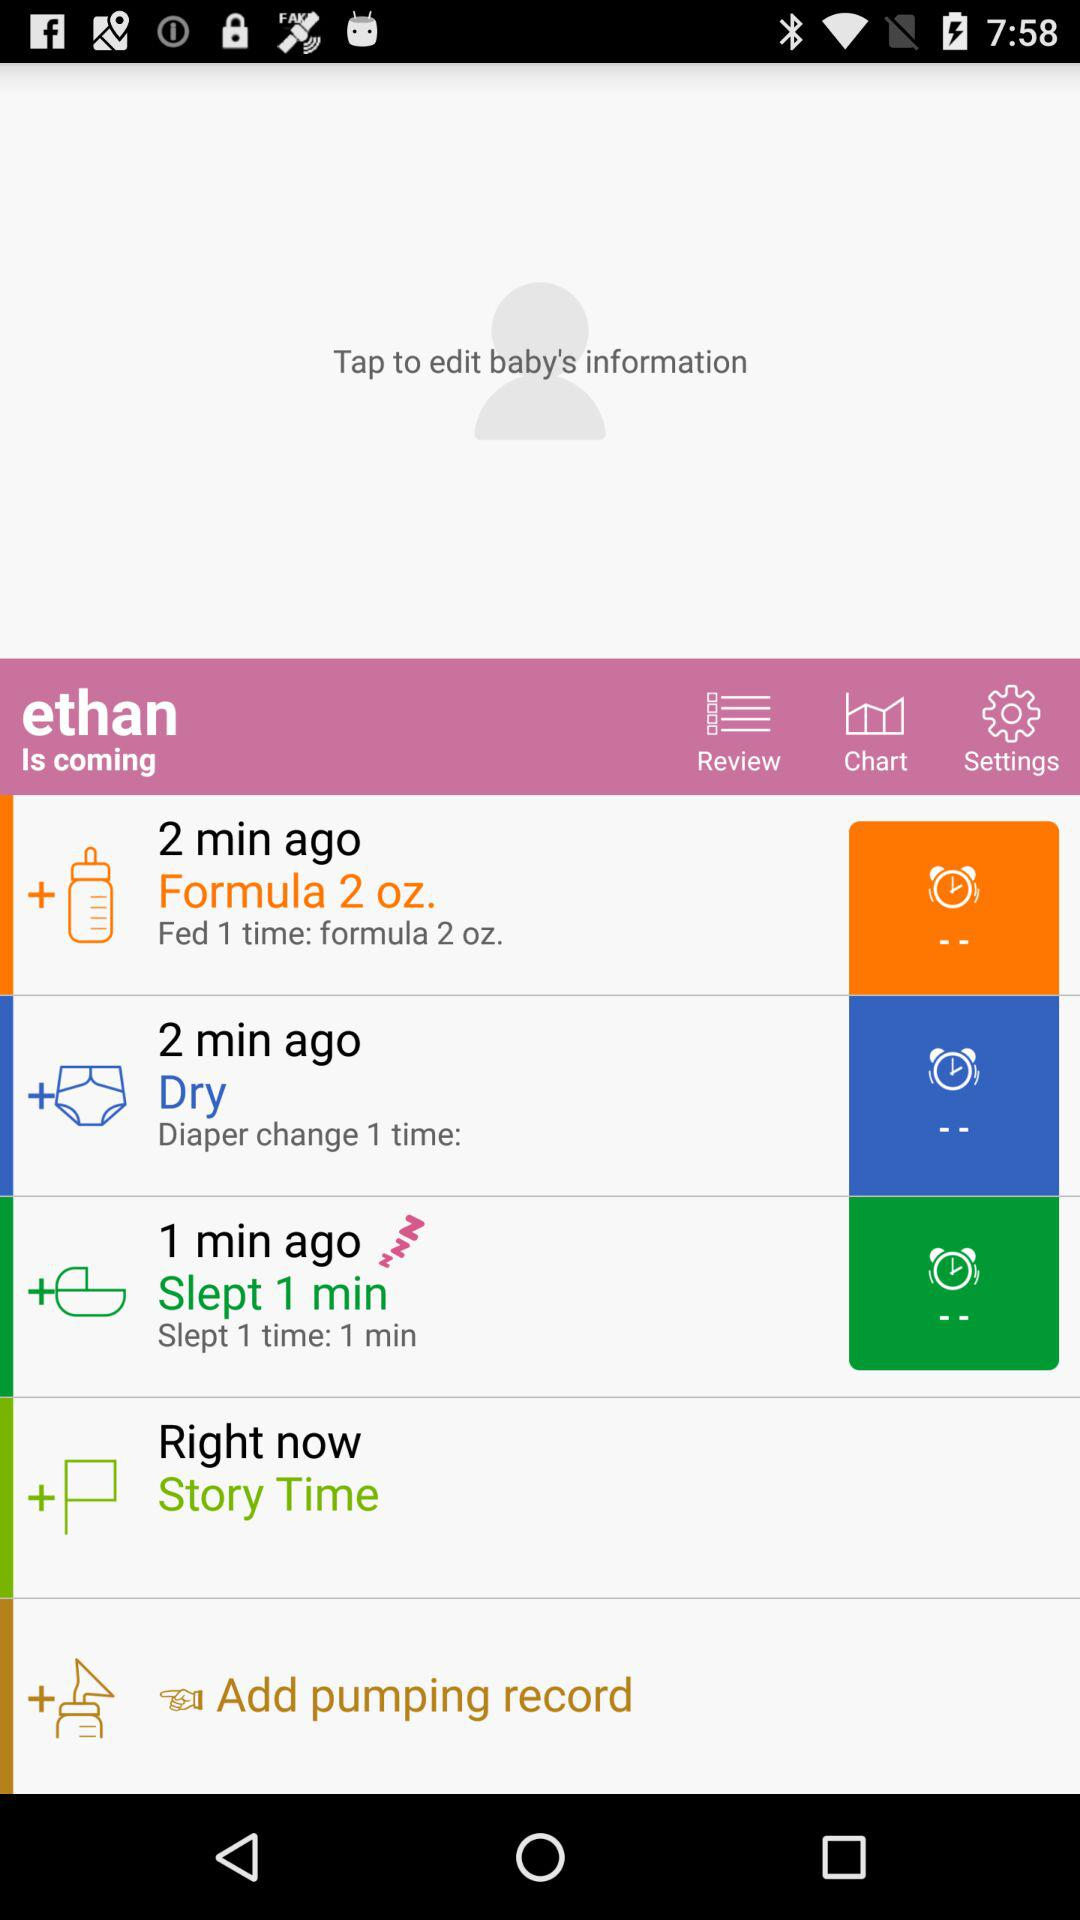How long ago was the diaper changed? The diaper was changed 2 minutes ago. 